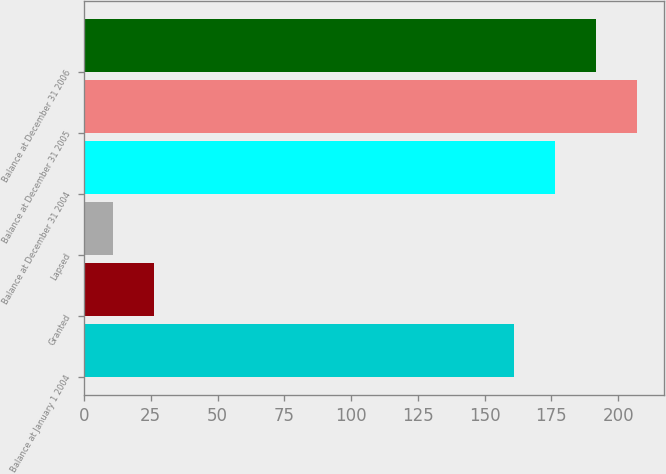Convert chart. <chart><loc_0><loc_0><loc_500><loc_500><bar_chart><fcel>Balance at January 1 2004<fcel>Granted<fcel>Lapsed<fcel>Balance at December 31 2004<fcel>Balance at December 31 2005<fcel>Balance at December 31 2006<nl><fcel>161<fcel>26.3<fcel>11<fcel>176.3<fcel>206.9<fcel>191.6<nl></chart> 